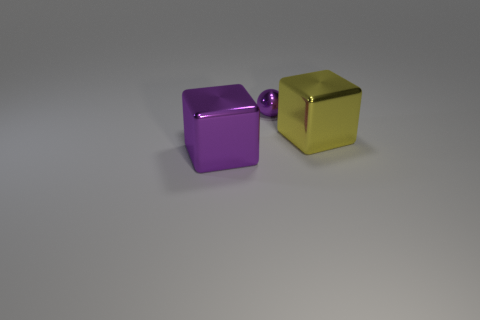The object that is both behind the purple block and in front of the tiny object is made of what material?
Keep it short and to the point. Metal. There is a small metal object; is it the same shape as the big shiny thing to the right of the large purple metallic block?
Ensure brevity in your answer.  No. What material is the big cube right of the shiny cube in front of the big block that is behind the large purple metallic block?
Keep it short and to the point. Metal. What number of other things are there of the same size as the metallic ball?
Provide a succinct answer. 0. There is a large thing that is left of the object that is behind the yellow metallic thing; what number of metal blocks are behind it?
Your answer should be very brief. 1. What is the material of the large object that is behind the cube that is to the left of the yellow metallic object?
Offer a very short reply. Metal. Are there any large yellow shiny things of the same shape as the big purple thing?
Keep it short and to the point. Yes. The cube that is the same size as the yellow thing is what color?
Give a very brief answer. Purple. What number of things are things that are on the right side of the large purple thing or metallic objects that are behind the yellow object?
Make the answer very short. 2. How many objects are either large yellow metal blocks or yellow cylinders?
Give a very brief answer. 1. 